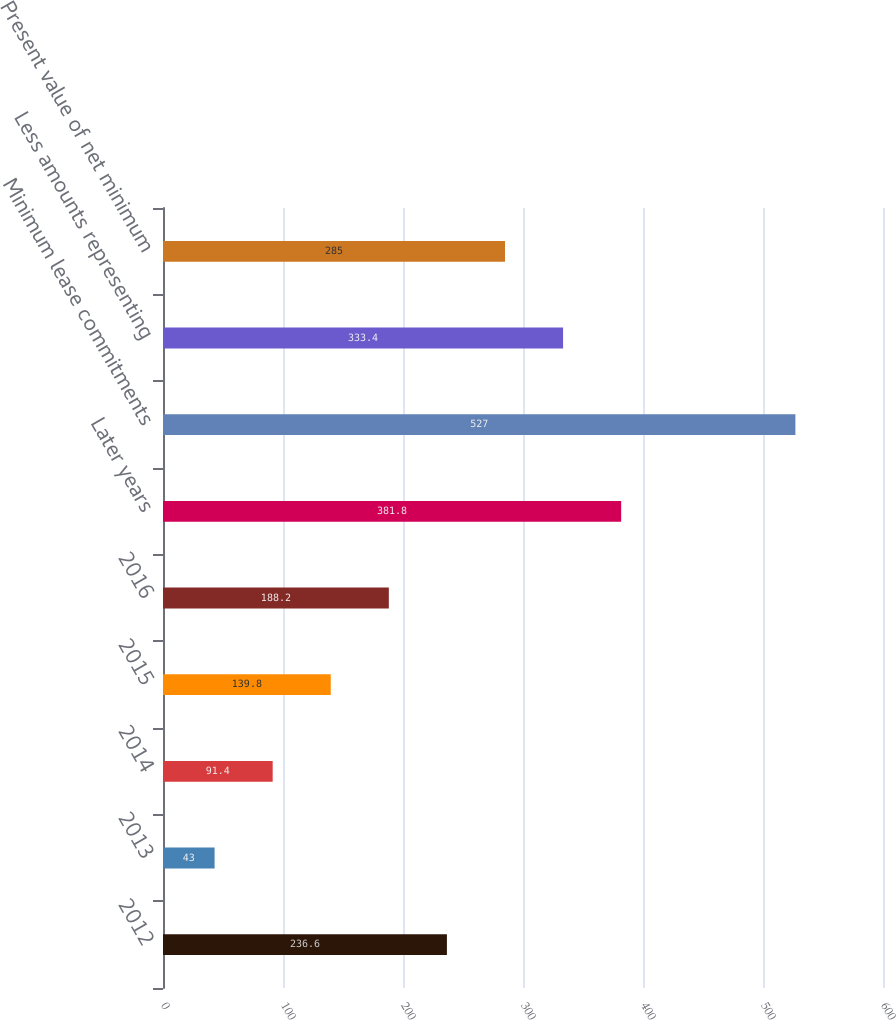<chart> <loc_0><loc_0><loc_500><loc_500><bar_chart><fcel>2012<fcel>2013<fcel>2014<fcel>2015<fcel>2016<fcel>Later years<fcel>Minimum lease commitments<fcel>Less amounts representing<fcel>Present value of net minimum<nl><fcel>236.6<fcel>43<fcel>91.4<fcel>139.8<fcel>188.2<fcel>381.8<fcel>527<fcel>333.4<fcel>285<nl></chart> 